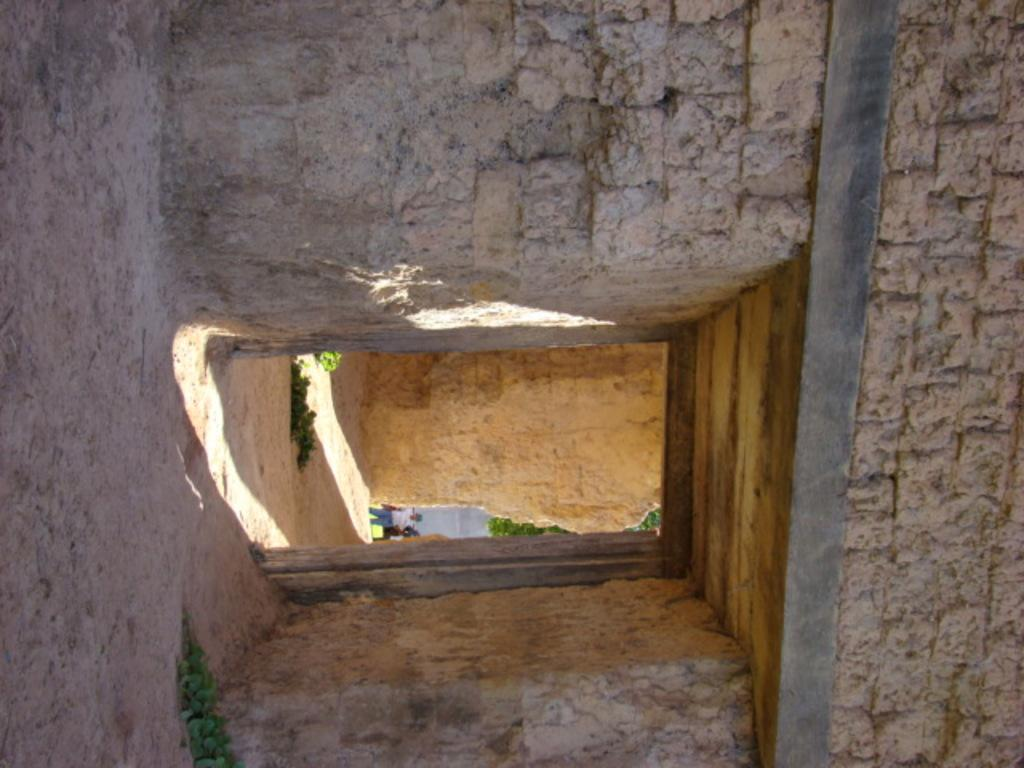What type of building is in the image? There is a rock building in the image. What can be seen in the background of the image? There are trees in the background of the image. What is the person wearing in the image? The person is wearing a white shirt and blue jeans. What other objects can be seen in the image? There are other objects visible in the image, but their specific details are not mentioned in the provided facts. What activity is the person experiencing in the image? There is no specific activity mentioned or depicted in the image. The person is simply standing, and no other actions or experiences are described. 